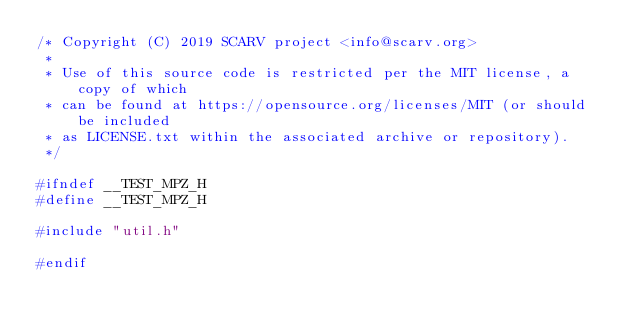<code> <loc_0><loc_0><loc_500><loc_500><_C_>/* Copyright (C) 2019 SCARV project <info@scarv.org>
 *
 * Use of this source code is restricted per the MIT license, a copy of which 
 * can be found at https://opensource.org/licenses/MIT (or should be included 
 * as LICENSE.txt within the associated archive or repository).
 */

#ifndef __TEST_MPZ_H
#define __TEST_MPZ_H

#include "util.h"

#endif
</code> 